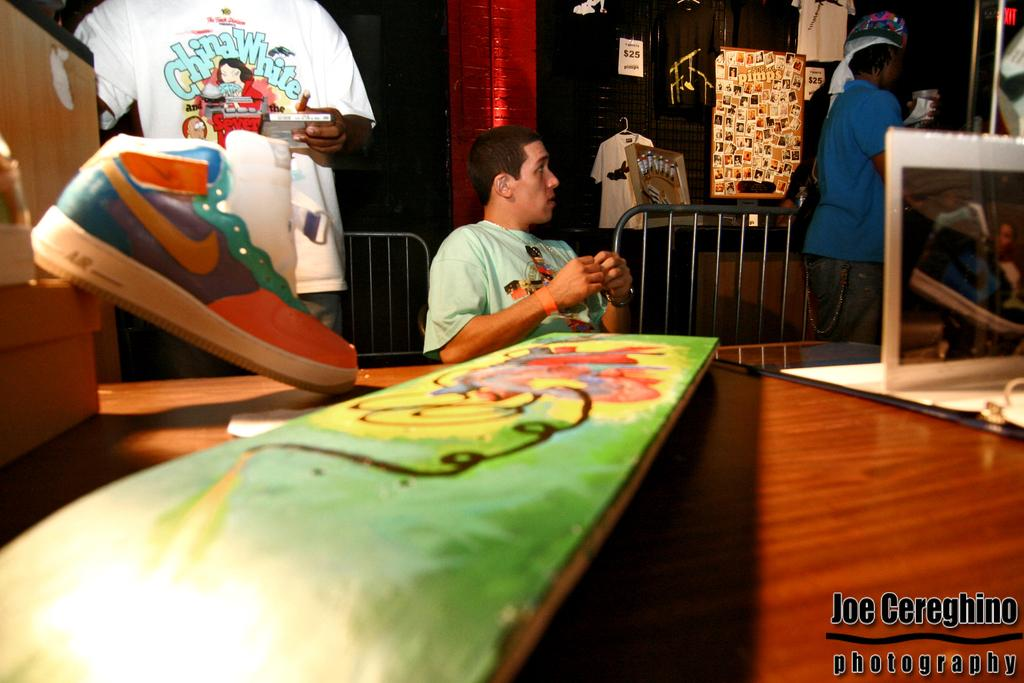<image>
Describe the image concisely. a man wearing a shirt that says 'china white' on it 